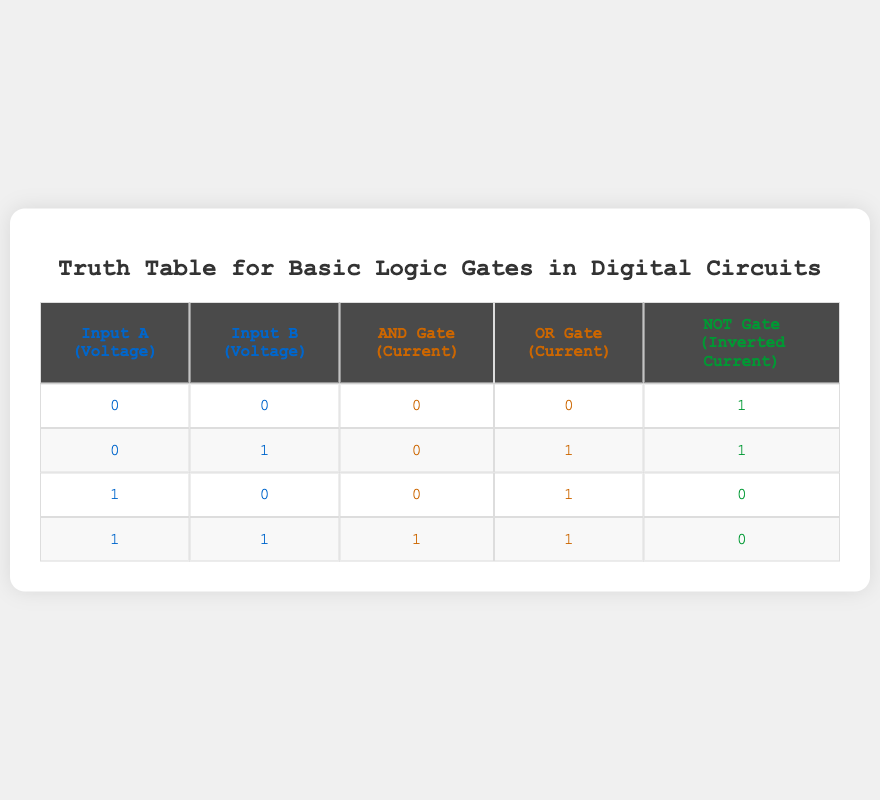What is the output of the AND gate when both inputs are 1? From the table, when Input A and Input B both equal 1, the AND gate's output is listed as 1.
Answer: 1 How many current values are 0 in the AND gate column? By examining the AND Gate column, we see there are three rows where the output is 0, which corresponds to the combinations (0,0), (0,1), and (1,0).
Answer: 3 What is the output of the NOT gate when Input A is 1? Reviewing the NOT Gate column for rows where Input A is 1, we find that the outputs for the combinations (1,0) and (1,1) are 0.
Answer: 0 Is there any situation where the AND gate outputs 1 while the OR gate outputs 0? Looking through the table, there's no instance where the AND Gate outputs 1 and the OR Gate outputs 0; they output the same values or have the AND Gate outputting 0 when the OR gate outputs 1.
Answer: No If both inputs are set to 0, what is the value of the OR gate current? The table indicates that when both Input A and Input B are 0, the OR gate’s output is 0.
Answer: 0 When Input A is 1 and Input B is 0, what is the NOT gate current value? In the table, when Input A is 1 and Input B is 0, the NOT gate outputs 0.
Answer: 0 What is the total number of AND gate outputs that are 0? The table provides three rows with a 0 output for the AND gate: (0,0), (0,1), and (1,0), hence the total is 3.
Answer: 3 What can be inferred about the NOT gate output when Input B is 0, regardless of Input A? The NOT gate output changes depending on Input A. When A is 0, the NOT output is 1, and when A is 1, the NOT output is 0, indicating that Input A influences the NOT gate's output in this case.
Answer: It depends on Input A When both inputs are 0, what are the outputs of all gates? For Input A = 0 and Input B = 0, the AND Gate outputs 0, the OR Gate outputs 0, and the NOT Gate outputs 1, indicating that when both inputs are 0, the AND and OR gates are inactive while the NOT gate is active.
Answer: AND: 0, OR: 0, NOT: 1 